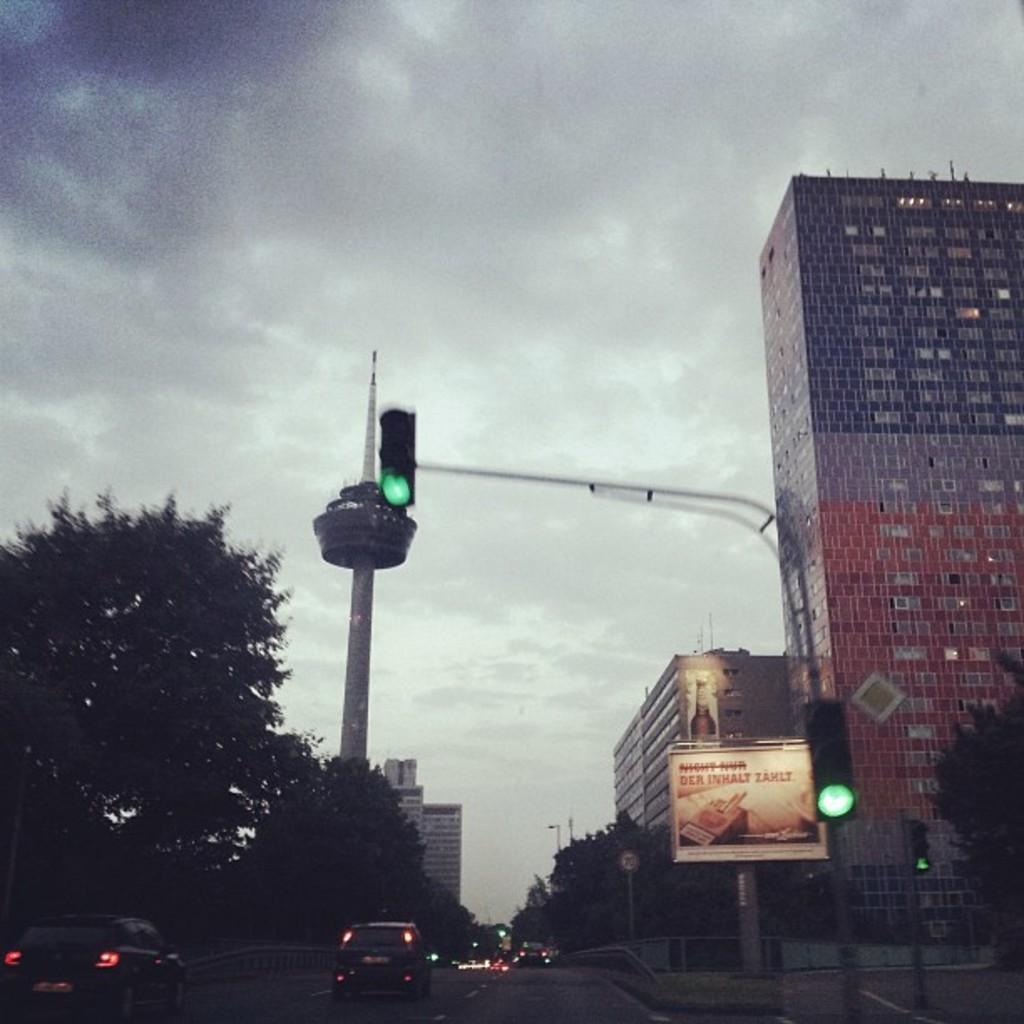Describe this image in one or two sentences. In this image I can see some vehicles on the road. On the left side I can see the trees. On the right side, I can see the buildings. In the background, I can see the sky. 